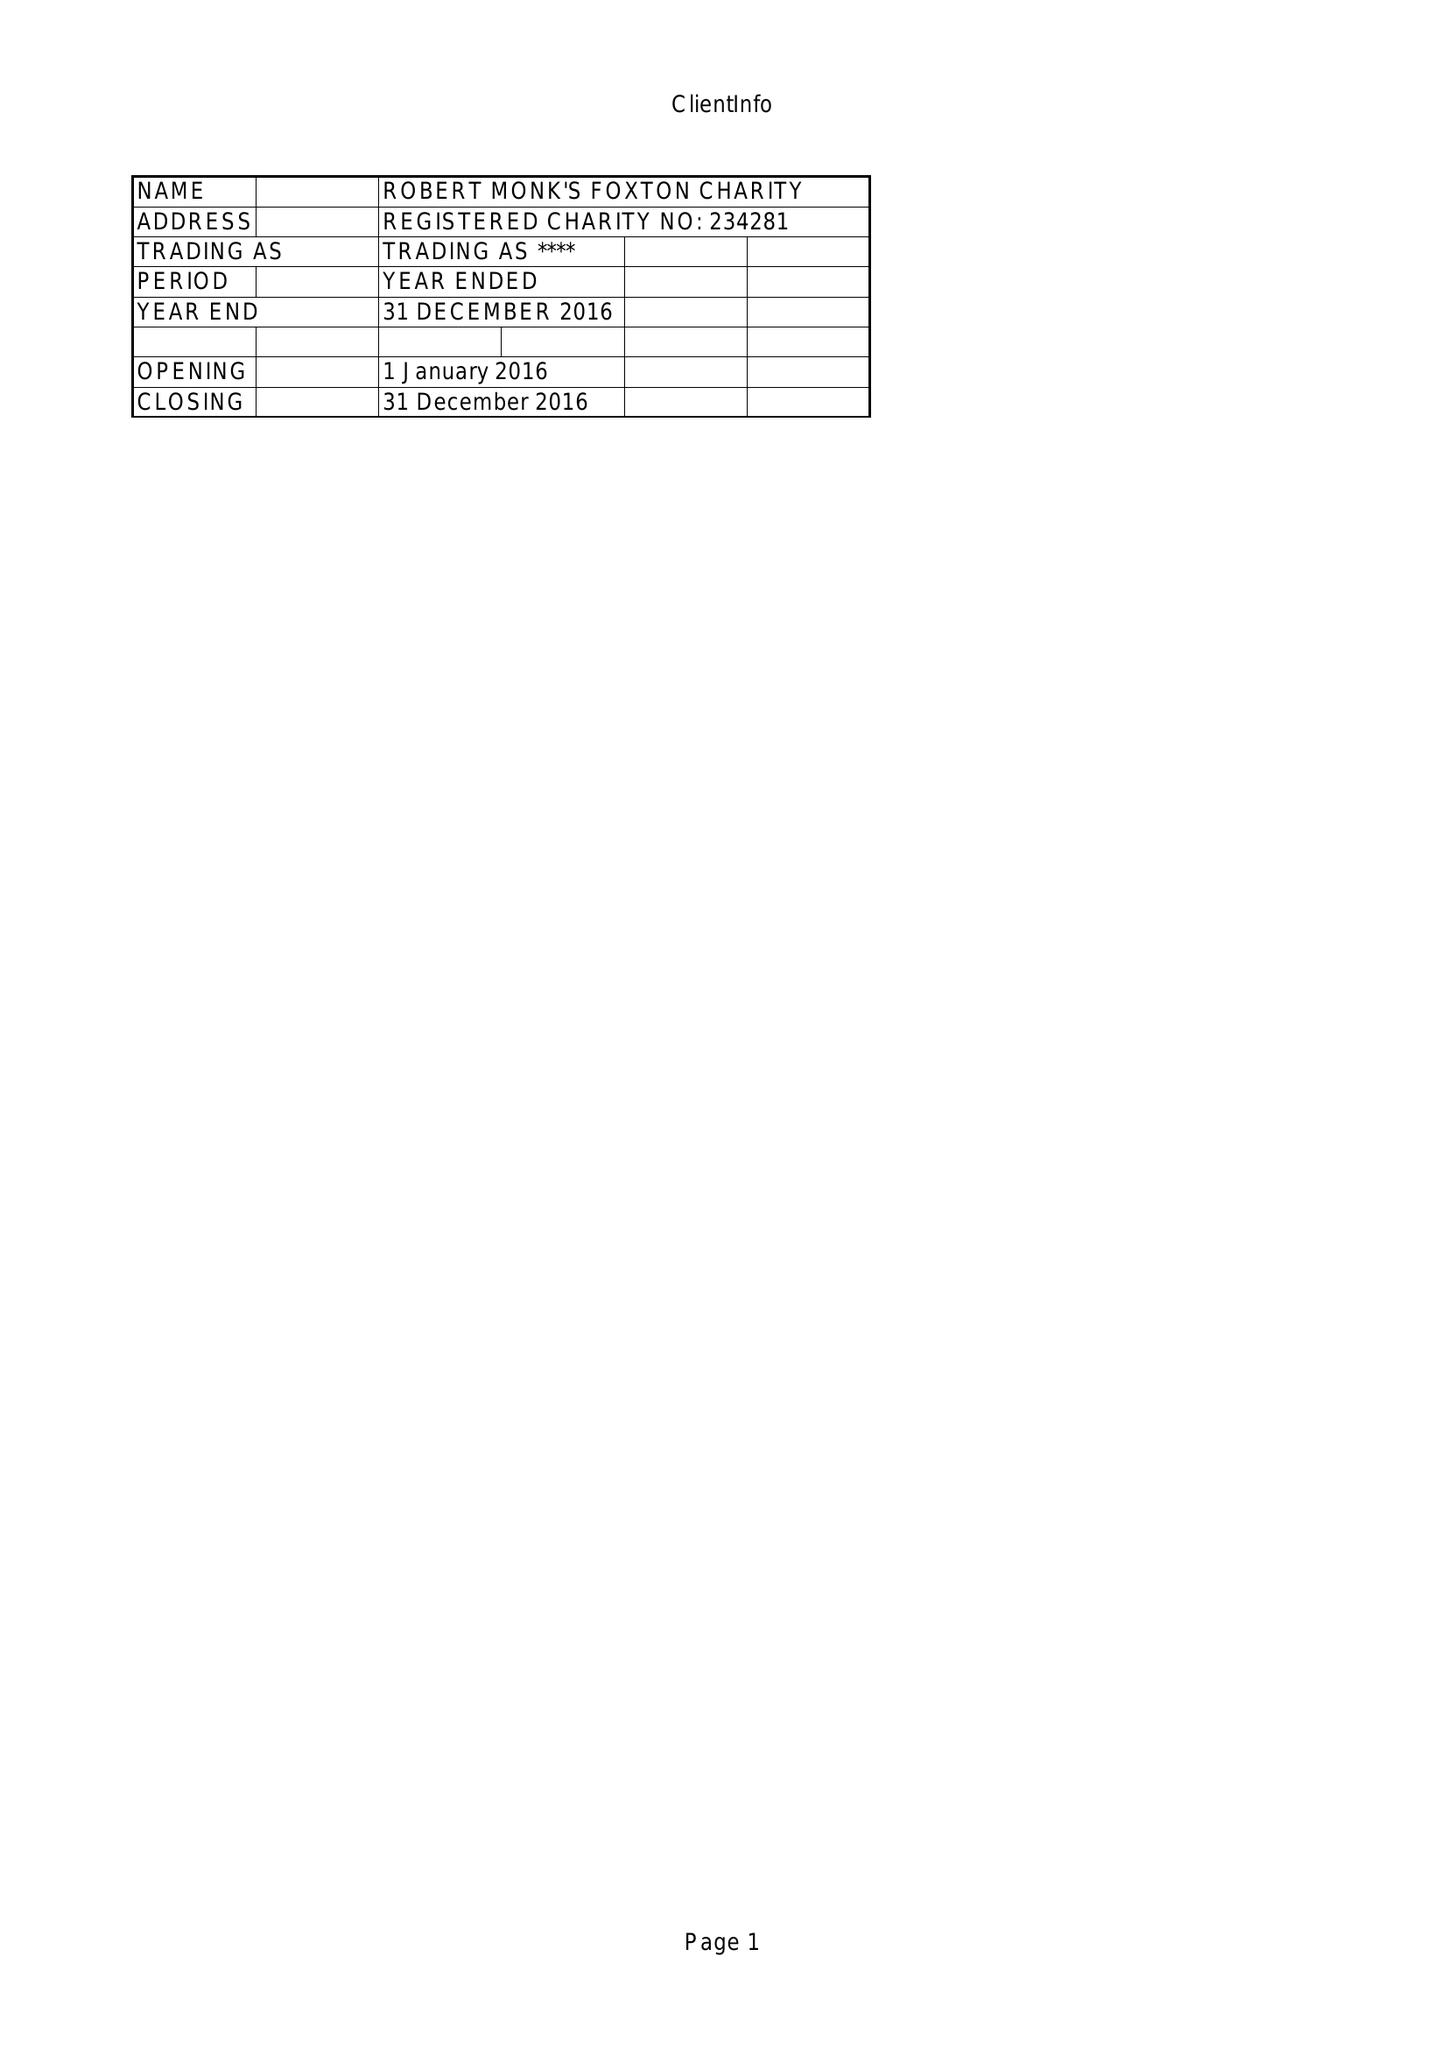What is the value for the charity_number?
Answer the question using a single word or phrase. 234281 